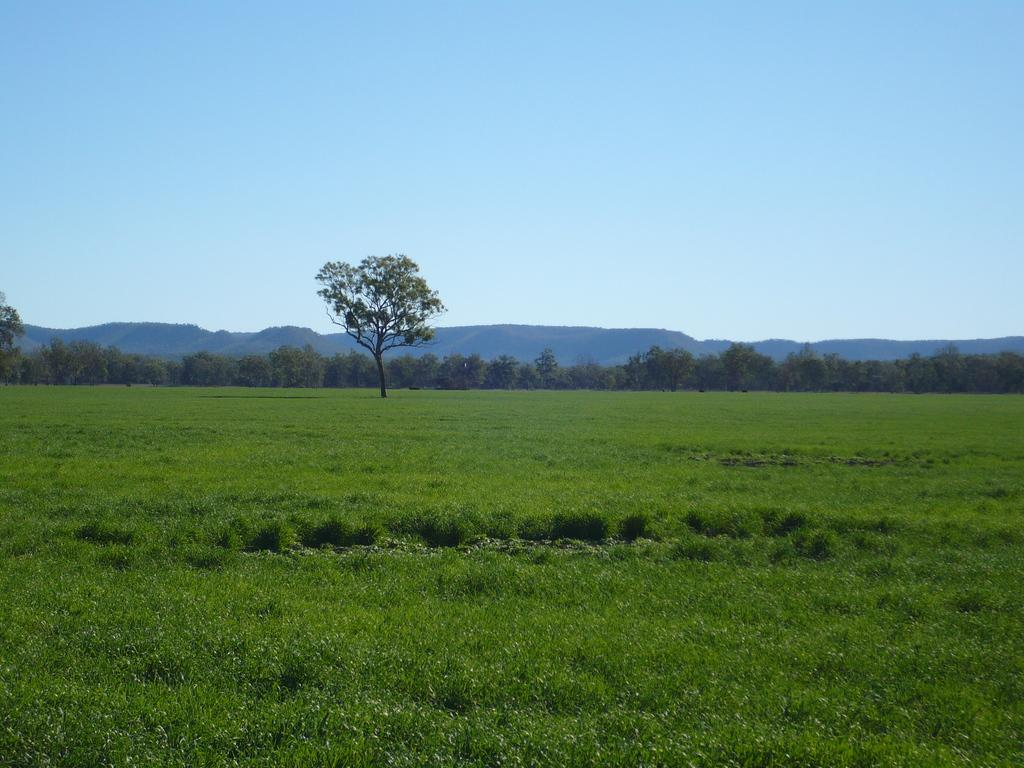What type of vegetation is at the bottom of the image? There is grass and plants at the bottom of the image. What natural features can be seen in the background of the image? There are mountains and trees in the background of the image. What is visible at the top of the image? The sky is visible at the top of the image. What channel is the belief system being broadcasted on in the image? There is no reference to a belief system or a channel in the image, so it is not possible to answer that question. 